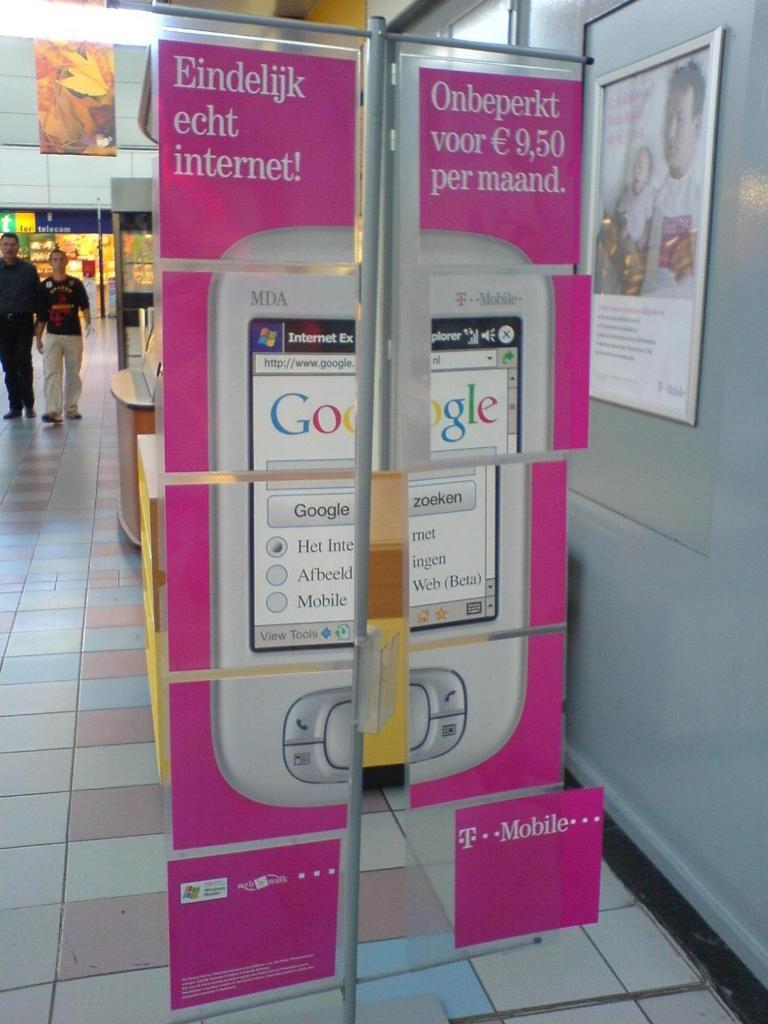<image>
Render a clear and concise summary of the photo. a poster that is above tile that says Google 